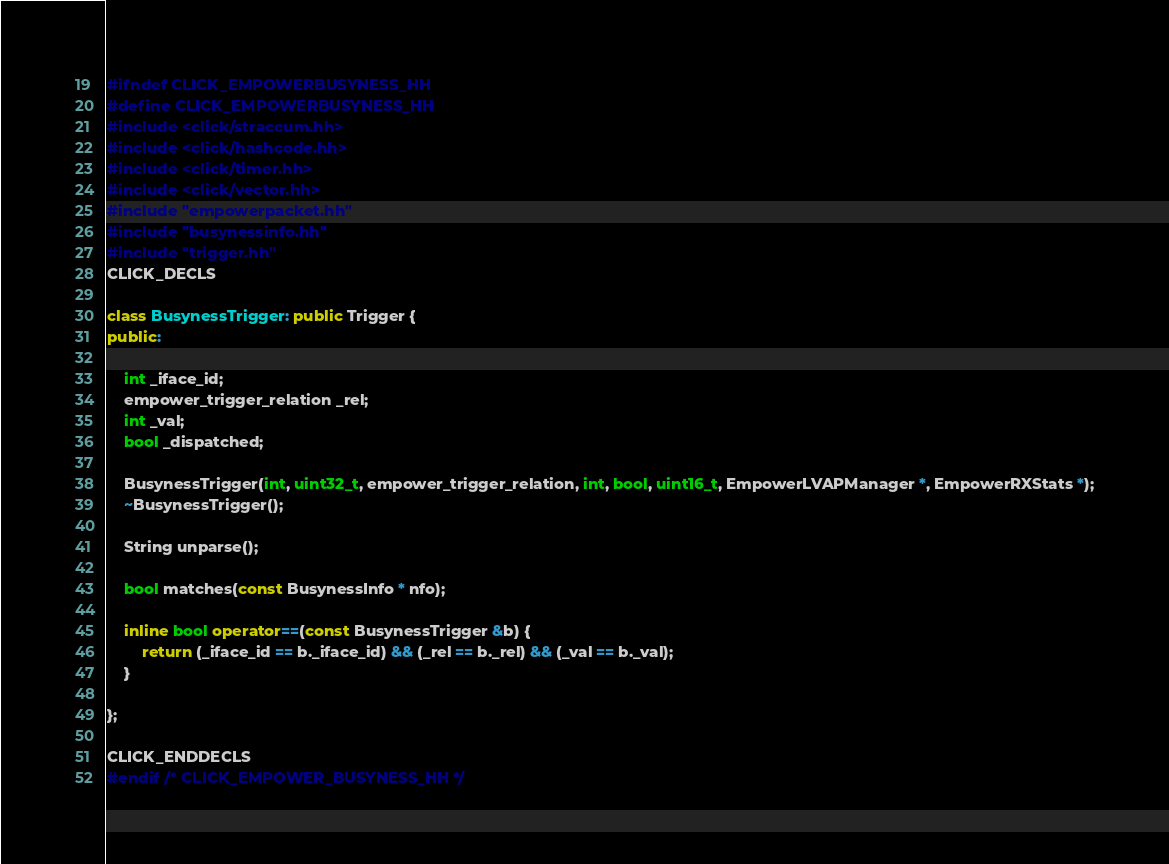<code> <loc_0><loc_0><loc_500><loc_500><_C++_>#ifndef CLICK_EMPOWERBUSYNESS_HH
#define CLICK_EMPOWERBUSYNESS_HH
#include <click/straccum.hh>
#include <click/hashcode.hh>
#include <click/timer.hh>
#include <click/vector.hh>
#include "empowerpacket.hh"
#include "busynessinfo.hh"
#include "trigger.hh"
CLICK_DECLS

class BusynessTrigger: public Trigger {
public:

	int _iface_id;
	empower_trigger_relation _rel;
	int _val;
	bool _dispatched;

	BusynessTrigger(int, uint32_t, empower_trigger_relation, int, bool, uint16_t, EmpowerLVAPManager *, EmpowerRXStats *);
	~BusynessTrigger();

	String unparse();

	bool matches(const BusynessInfo * nfo);

	inline bool operator==(const BusynessTrigger &b) {
		return (_iface_id == b._iface_id) && (_rel == b._rel) && (_val == b._val);
	}

};

CLICK_ENDDECLS
#endif /* CLICK_EMPOWER_BUSYNESS_HH */
</code> 